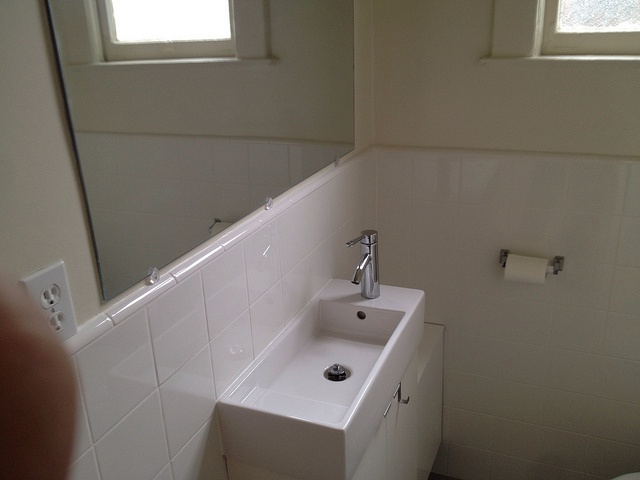Describe the objects in this image and their specific colors. I can see a sink in gray and darkgray tones in this image. 